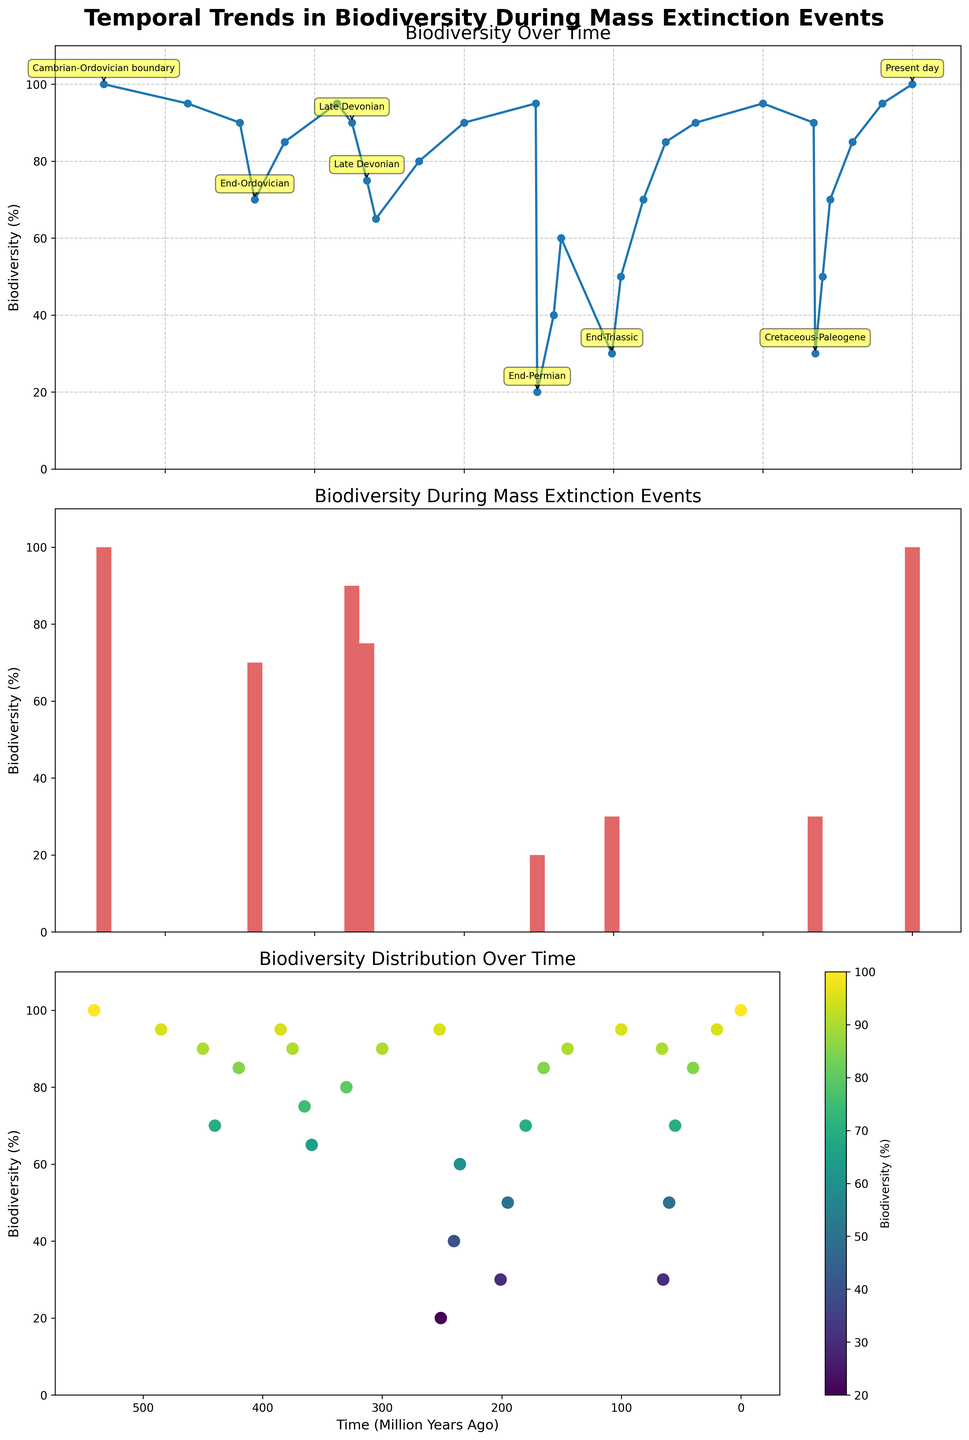What's the general trend of biodiversity over time from 541 million years ago to the present? Looking at the line plot on the first subplot, biodiversity starts at 100%, fluctuates with notable declines at specific points, and eventually returns to 100% in the present day. This indicates a generally resilient recovery despite multiple mass extinction events.
Answer: Biodiversity fluctuates and recovers to 100% Which mass extinction event caused the most significant drop in biodiversity according to the bar plot? The bar plot in the second subplot shows the biodiversity drop for each mass extinction event. The End-Permian event (252 Mya) shows a drop to 20% from the previous value of 95%. This is the most significant decrease.
Answer: End-Permian How does the distribution of biodiversity look in the scatter plot over time? The scatter plot in the third subplot shows points spread across different times with a color gradient from yellow to dark green. The points indicate periods of low biodiversity that gradually recover, suggesting natural recoveries between extinction events.
Answer: Points spread, showing fluctuation and recovery What's the difference in biodiversity between the Late Devonian extinction events at 375 Mya and 365 Mya? Referring to the line plot and bar plot, the biodiversity at 375 Mya is 90%, and at 365 Mya is 75%. The difference is 90% - 75% = 15%.
Answer: 15% Which time period had a biodiversity level closest to the present day, excluding mass extinction events? Observing the line plot, the point closest to 100% (present day) is 541 Mya, also at 100%. This was not categorized as a mass extinction event according to the annotations on the bar plot.
Answer: 541 Mya How many mass extinction events are documented in the bar plot, and what are their approximate time periods? The bar plot highlights five mass extinction events with biodiversity declines. They are documented at:
1. Cambrian-Ordovician (485 Mya)
2. End-Ordovician (440 Mya)
3. Late Devonian (375 Mya and 365 Mya)
4. End-Permian (252 Mya)
5. End-Triassic (201 Mya)
6. Cretaceous-Paleogene (65 Mya)
Answer: Six events: 485, 440, 375, 365, 252, 201, 65 Mya What visual patterns can be observed in the scatter plot concerning the relationship between time and biodiversity level? In the scatter plot, darker green indicates higher biodiversity closer to the present time, while yellow signifies lower biodiversity around mass extinction periods. Visually, darker points cluster towards modern times, and lighter points align with known extinction events.
Answer: Darker points near present, lighter points at extinction times Which extinction event has the second-largest drop in biodiversity according to the line plot? The line plot shows that the Cretaceous-Paleogene extinction (65 Mya) caused biodiversity to drop to 30% from the previous value of 90%, marking the second-largest drop after the End-Permian event.
Answer: Cretaceous-Paleogene What was the biodiversity level immediately after the End-Permian extinction event? The line plot shows that immediately after the End-Permian extinction event at 252 Mya, biodiversity was at 20%.
Answer: 20% How does the biodiversity at the End-Ordovician extinction compare to the Cambrian-Ordovician boundary? From the line plot, the biodiversity at the Cambrian-Ordovician boundary (485Mya) was 95%. During the End-Ordovician extinction (440 Mya), it was 70%. Therefore, the biodiversity dropped by 25%.
Answer: Biodiversity dropped by 25% 